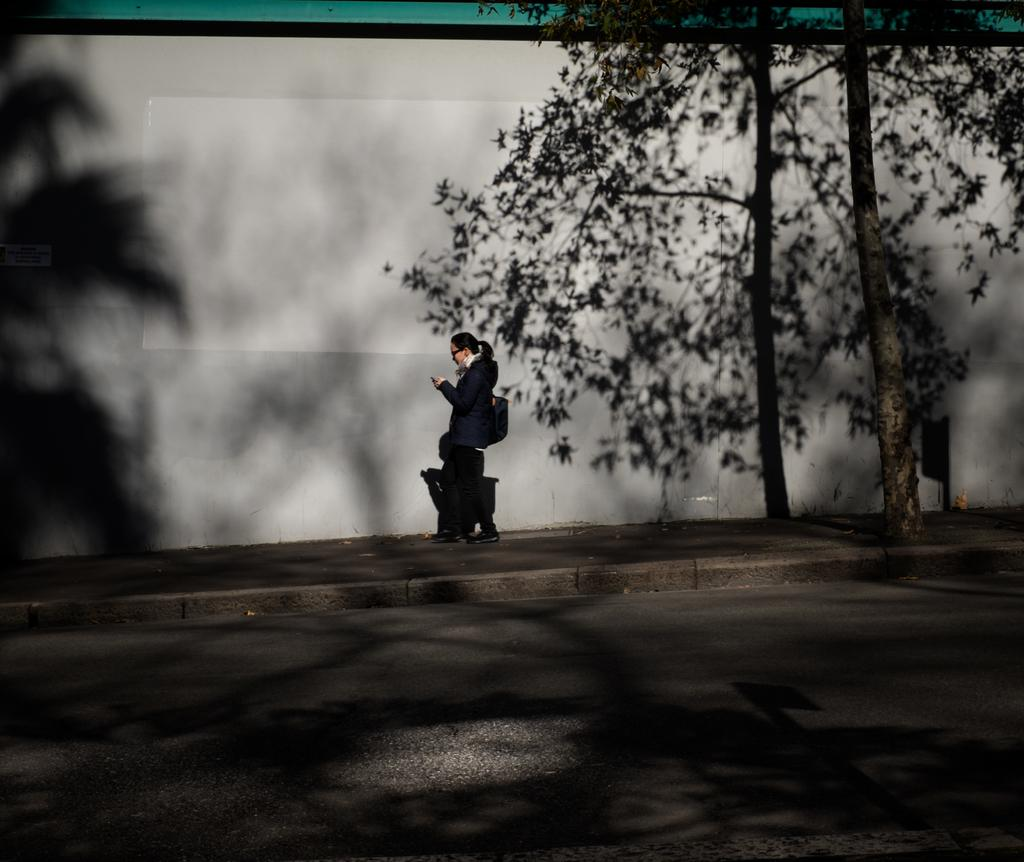Who is present in the image? There is a woman in the image. What is the woman wearing? The woman is wearing a suit. What is the woman holding in the image? The woman is holding a cellphone. What is the woman doing in the image? The woman is walking on a footpath. What can be seen on the right side of the image? There is a tree on the right side of the image. What is in front of the woman? There is a road in front of the woman. What is beside the woman? There is a wall beside the woman. How many cows are grazing on the grass beside the wall in the image? There are no cows present in the image; it only features a woman walking on a footpath, a tree, a road, and a wall. 